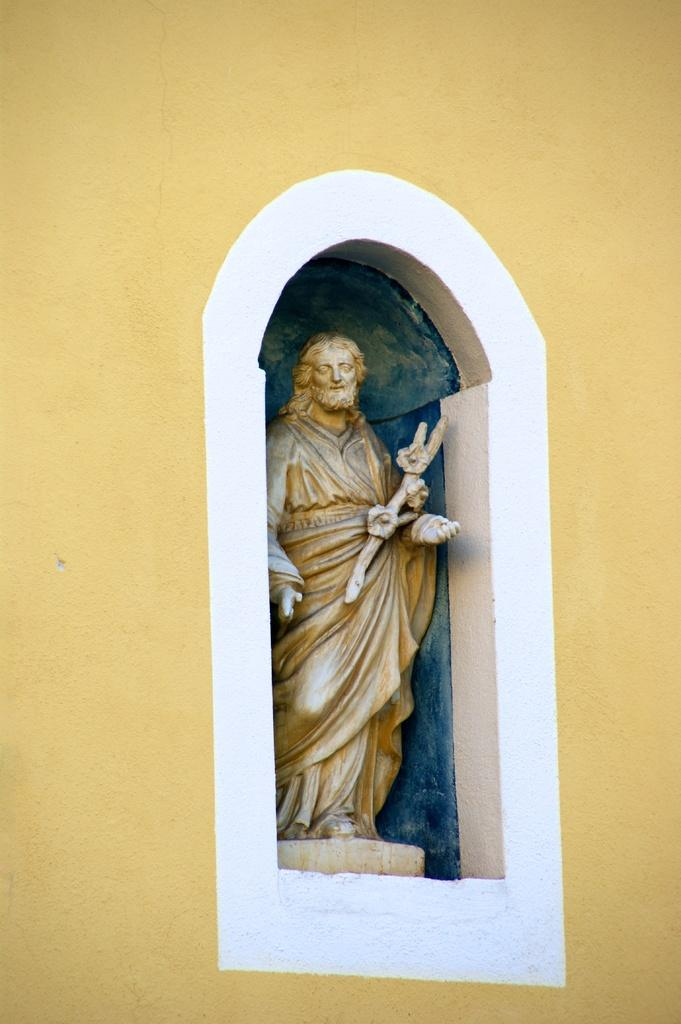What is the main subject in the image? There is a statue in the image. What else can be seen in the image besides the statue? There is a wall in the image. What thoughts are the fairies having while standing next to the statue in the image? There are no fairies present in the image, so it is not possible to determine their thoughts. 